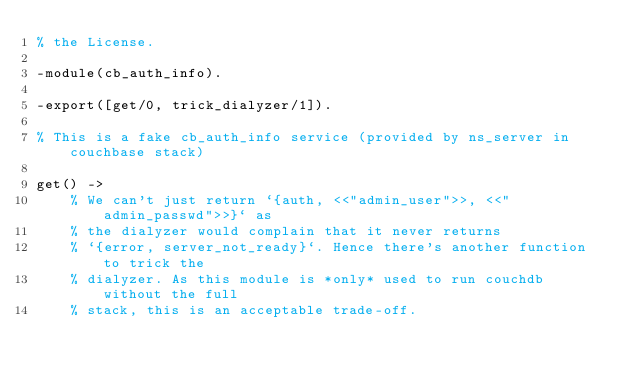<code> <loc_0><loc_0><loc_500><loc_500><_Erlang_>% the License.

-module(cb_auth_info).

-export([get/0, trick_dialyzer/1]).

% This is a fake cb_auth_info service (provided by ns_server in couchbase stack)

get() ->
    % We can't just return `{auth, <<"admin_user">>, <<"admin_passwd">>}` as
    % the dialyzer would complain that it never returns
    % `{error, server_not_ready}`. Hence there's another function to trick the
    % dialyzer. As this module is *only* used to run couchdb without the full
    % stack, this is an acceptable trade-off.</code> 